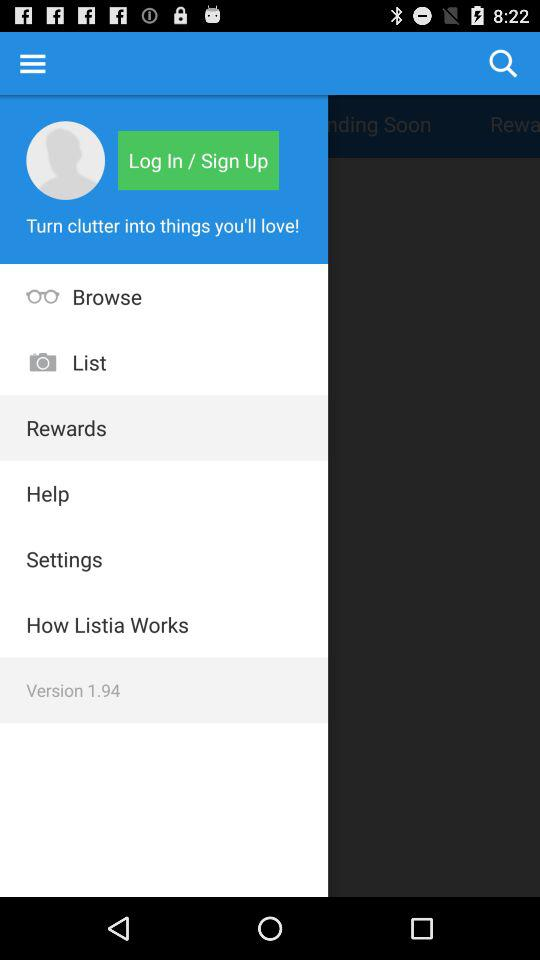What is the version of the application? The version of the application is 1.94. 